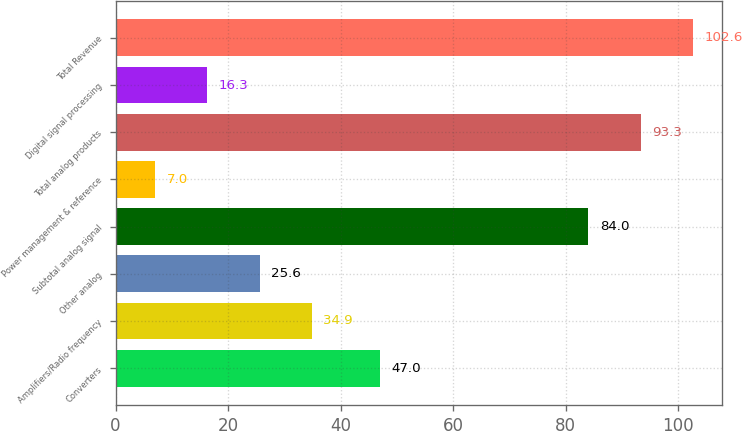Convert chart to OTSL. <chart><loc_0><loc_0><loc_500><loc_500><bar_chart><fcel>Converters<fcel>Amplifiers/Radio frequency<fcel>Other analog<fcel>Subtotal analog signal<fcel>Power management & reference<fcel>Total analog products<fcel>Digital signal processing<fcel>Total Revenue<nl><fcel>47<fcel>34.9<fcel>25.6<fcel>84<fcel>7<fcel>93.3<fcel>16.3<fcel>102.6<nl></chart> 